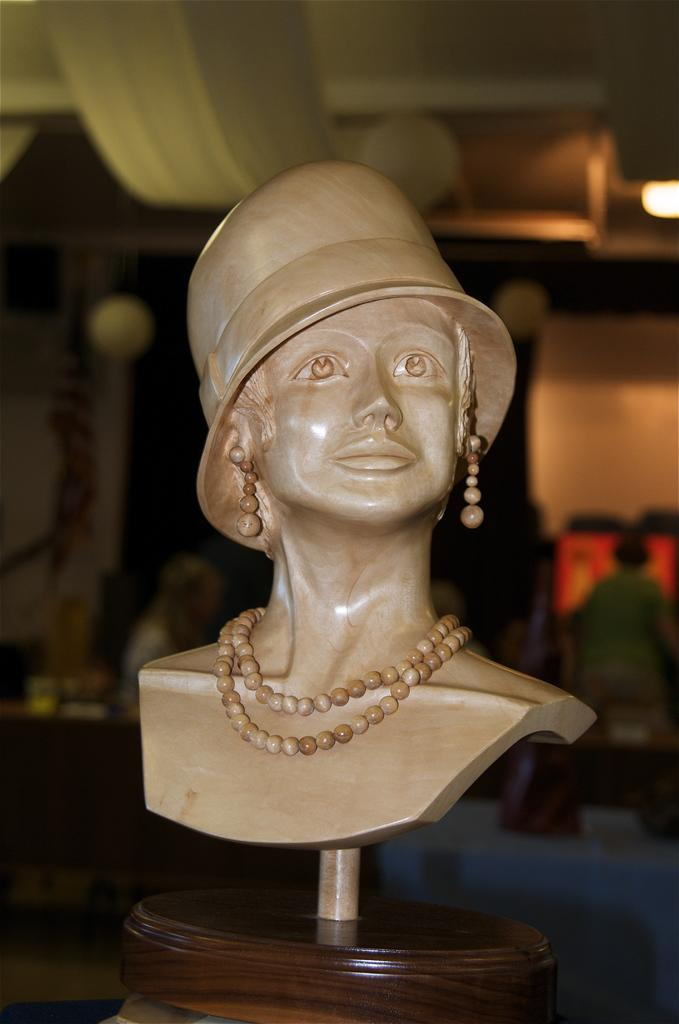What is the main subject of the image? There is a sculpture in the image. What is the sculpture depicting? The sculpture is of a person. What accessories is the person in the sculpture wearing? The person in the sculpture is wearing a hat, earrings, and a necklace. What type of punishment is being administered to the person in the sculpture? There is no punishment being administered to the person in the sculpture; it is a sculpture of a person wearing a hat, earrings, and a necklace. What is the person in the sculpture using to write on the desk? There is no desk or writing activity present in the image; it is a sculpture of a person wearing a hat, earrings, and a necklace. 